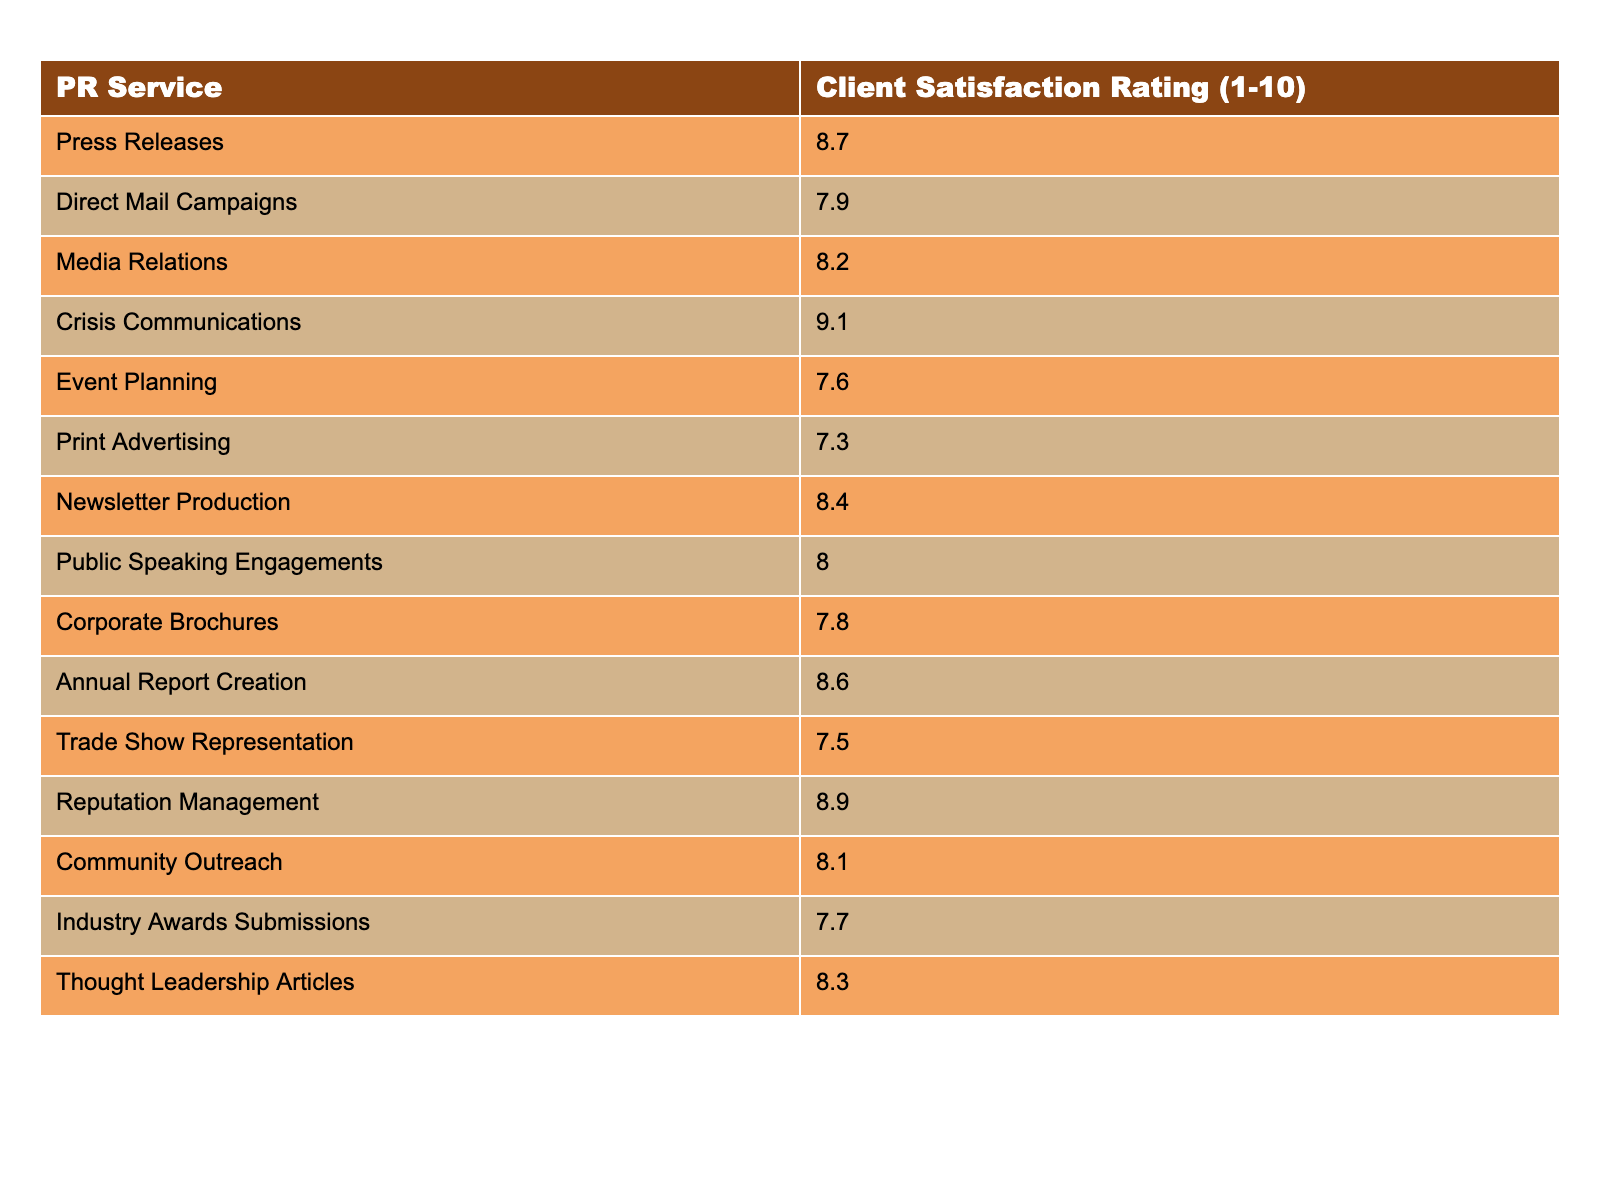What is the client satisfaction rating for Press Releases? The table shows the rating for Press Releases is listed as 8.7.
Answer: 8.7 Which PR service has the highest client satisfaction rating? By reviewing the ratings, Crisis Communications has the highest rating at 9.1.
Answer: Crisis Communications What is the average client satisfaction rating for the services listed? Adding all ratings gives a total of 127.4, and dividing by the 15 services listed results in an average of 8.49.
Answer: 8.49 True or False: Event Planning has a higher satisfaction rating than Direct Mail Campaigns. The rating for Event Planning is 7.6 and for Direct Mail Campaigns it is 7.9, so Event Planning does not have a higher rating.
Answer: False What is the difference between the highest and lowest satisfaction ratings? The highest rating is 9.1 (Crisis Communications) and the lowest is 7.3 (Print Advertising). The difference is 9.1 - 7.3 = 1.8.
Answer: 1.8 Which PR service has a rating closest to 8.0? Looking at the data, Public Speaking Engagements at 8.0 matches directly, while Event Planning at 7.6 is the nearest lower option.
Answer: Public Speaking Engagements How many services have a rating of 8.0 or higher? Counting the ratings of 8.0 or higher, there are 8 services that meet this criterion.
Answer: 8 Which PR service has a rating below 8.0 but is higher than 7.5? Direct Mail Campaigns has a rating of 7.9, which is below 8.0 and above 7.5.
Answer: Direct Mail Campaigns Is the satisfaction rating for Community Outreach higher than for Print Advertising? The rating for Community Outreach is 8.1, while Print Advertising has a rating of 7.3, making Community Outreach higher.
Answer: Yes If you were to rank the PR services based on client satisfaction, how many services would fall within the range of 7.5 to 8.3? The services with ratings in the range of 7.5 to 8.3 are: Print Advertising (7.3), Trade Show Representation (7.5), Direct Mail Campaigns (7.9), Corporate Brochures (7.8), and Industry Awards Submissions (7.7), totaling 6 services in this range.
Answer: 6 